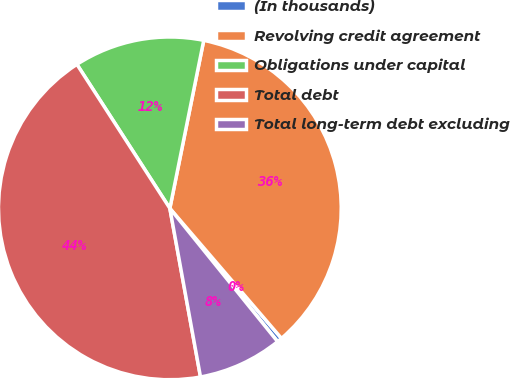<chart> <loc_0><loc_0><loc_500><loc_500><pie_chart><fcel>(In thousands)<fcel>Revolving credit agreement<fcel>Obligations under capital<fcel>Total debt<fcel>Total long-term debt excluding<nl><fcel>0.47%<fcel>35.54%<fcel>12.29%<fcel>43.74%<fcel>7.96%<nl></chart> 